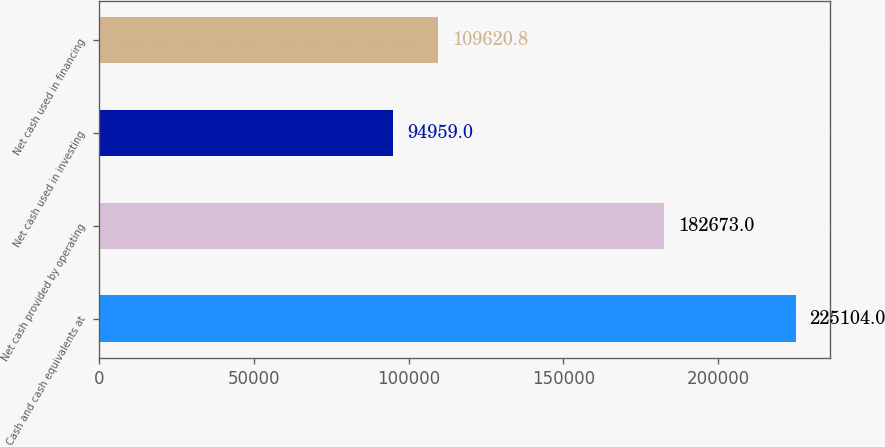Convert chart to OTSL. <chart><loc_0><loc_0><loc_500><loc_500><bar_chart><fcel>Cash and cash equivalents at<fcel>Net cash provided by operating<fcel>Net cash used in investing<fcel>Net cash used in financing<nl><fcel>225104<fcel>182673<fcel>94959<fcel>109621<nl></chart> 